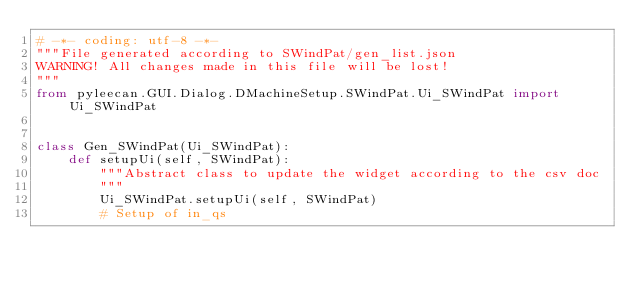<code> <loc_0><loc_0><loc_500><loc_500><_Python_># -*- coding: utf-8 -*-
"""File generated according to SWindPat/gen_list.json
WARNING! All changes made in this file will be lost!
"""
from pyleecan.GUI.Dialog.DMachineSetup.SWindPat.Ui_SWindPat import Ui_SWindPat


class Gen_SWindPat(Ui_SWindPat):
    def setupUi(self, SWindPat):
        """Abstract class to update the widget according to the csv doc
        """
        Ui_SWindPat.setupUi(self, SWindPat)
        # Setup of in_qs</code> 